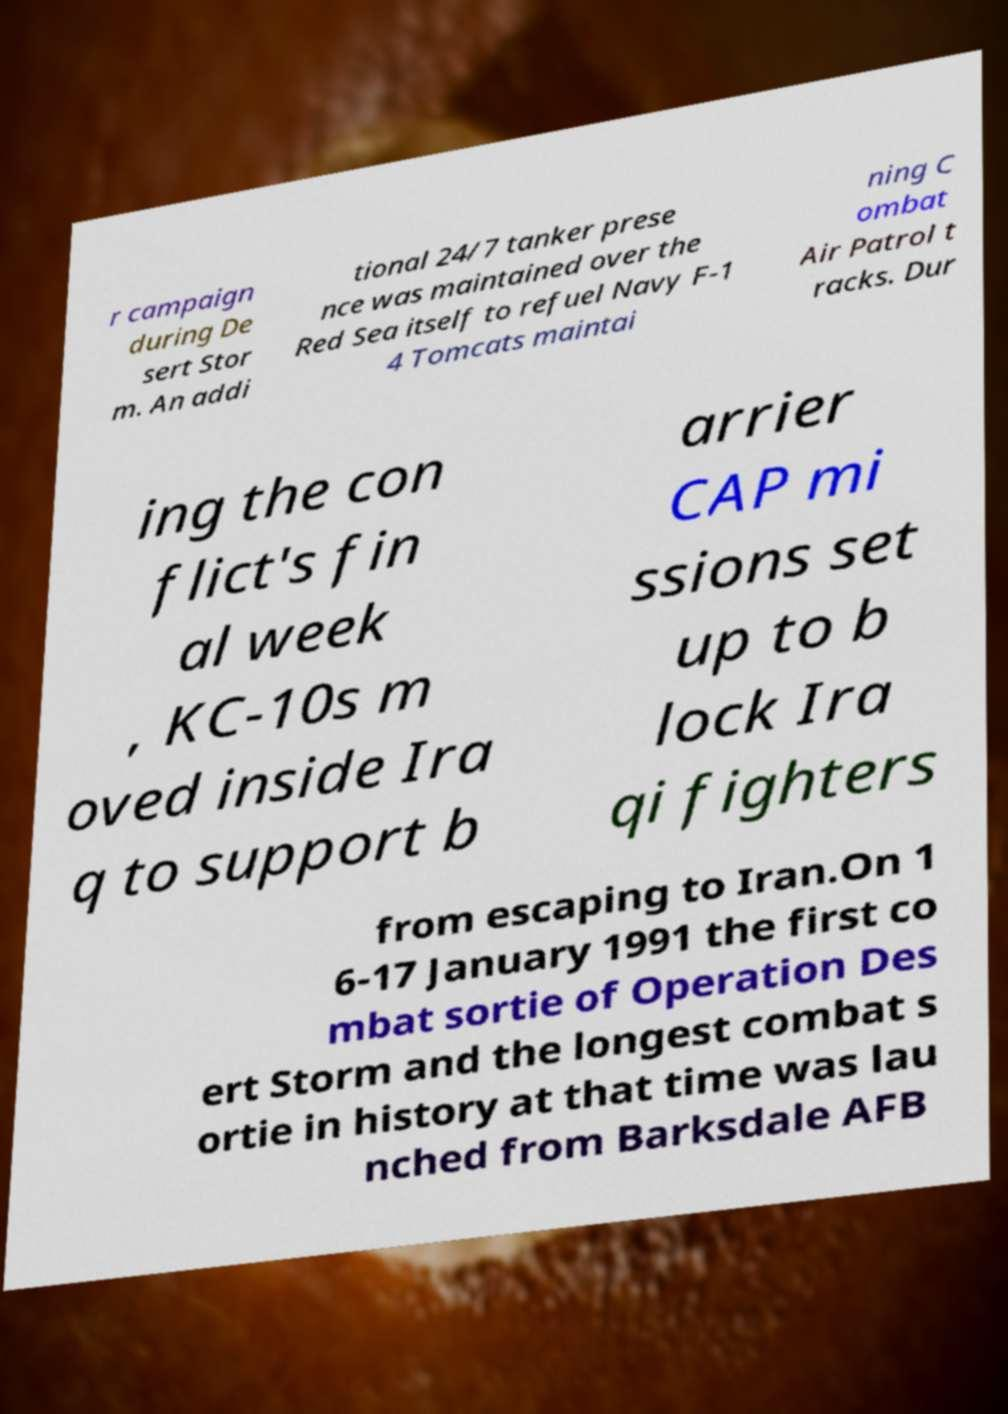For documentation purposes, I need the text within this image transcribed. Could you provide that? r campaign during De sert Stor m. An addi tional 24/7 tanker prese nce was maintained over the Red Sea itself to refuel Navy F-1 4 Tomcats maintai ning C ombat Air Patrol t racks. Dur ing the con flict's fin al week , KC-10s m oved inside Ira q to support b arrier CAP mi ssions set up to b lock Ira qi fighters from escaping to Iran.On 1 6-17 January 1991 the first co mbat sortie of Operation Des ert Storm and the longest combat s ortie in history at that time was lau nched from Barksdale AFB 